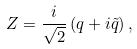Convert formula to latex. <formula><loc_0><loc_0><loc_500><loc_500>Z = \frac { i } { \sqrt { 2 } } \left ( { q + i \tilde { q } } \right ) ,</formula> 